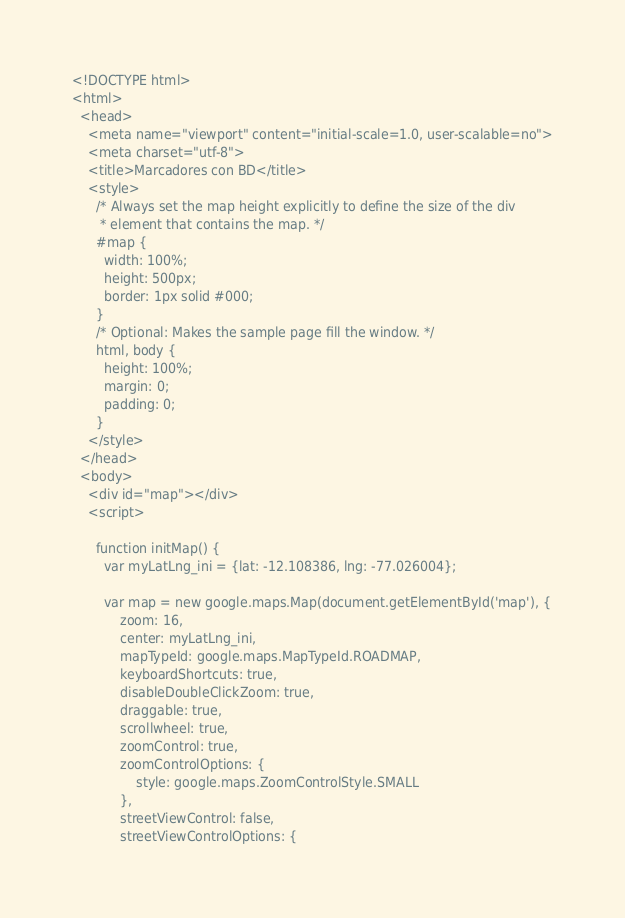Convert code to text. <code><loc_0><loc_0><loc_500><loc_500><_PHP_><!DOCTYPE html>
<html>
  <head>
    <meta name="viewport" content="initial-scale=1.0, user-scalable=no">
    <meta charset="utf-8">
    <title>Marcadores con BD</title>
    <style>
      /* Always set the map height explicitly to define the size of the div
       * element that contains the map. */
      #map {
        width: 100%;
        height: 500px;
        border: 1px solid #000;
      }
      /* Optional: Makes the sample page fill the window. */
      html, body {
        height: 100%;
        margin: 0;
        padding: 0;
      }
    </style>
  </head>
  <body>
    <div id="map"></div>
    <script>
        
      function initMap() {
        var myLatLng_ini = {lat: -12.108386, lng: -77.026004};

        var map = new google.maps.Map(document.getElementById('map'), {
            zoom: 16,
            center: myLatLng_ini,
            mapTypeId: google.maps.MapTypeId.ROADMAP,
            keyboardShortcuts: true,
            disableDoubleClickZoom: true,
            draggable: true,
            scrollwheel: true,
            zoomControl: true,
            zoomControlOptions: {
                style: google.maps.ZoomControlStyle.SMALL
            },
            streetViewControl: false,
            streetViewControlOptions: {</code> 